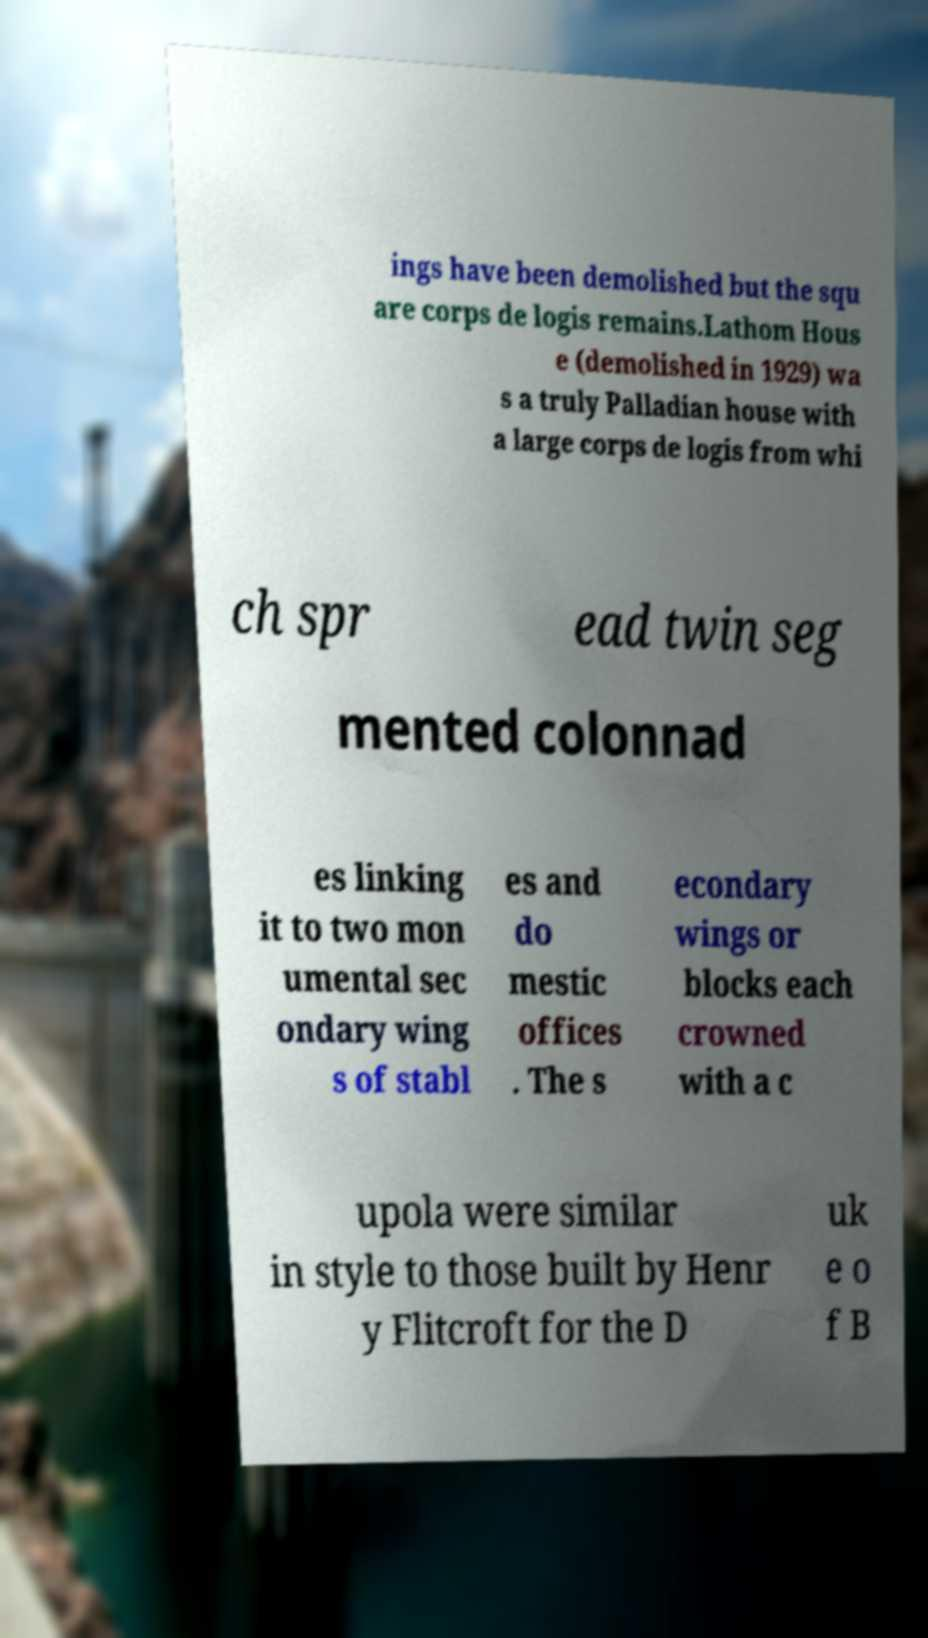For documentation purposes, I need the text within this image transcribed. Could you provide that? ings have been demolished but the squ are corps de logis remains.Lathom Hous e (demolished in 1929) wa s a truly Palladian house with a large corps de logis from whi ch spr ead twin seg mented colonnad es linking it to two mon umental sec ondary wing s of stabl es and do mestic offices . The s econdary wings or blocks each crowned with a c upola were similar in style to those built by Henr y Flitcroft for the D uk e o f B 